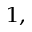<formula> <loc_0><loc_0><loc_500><loc_500>^ { 1 , }</formula> 